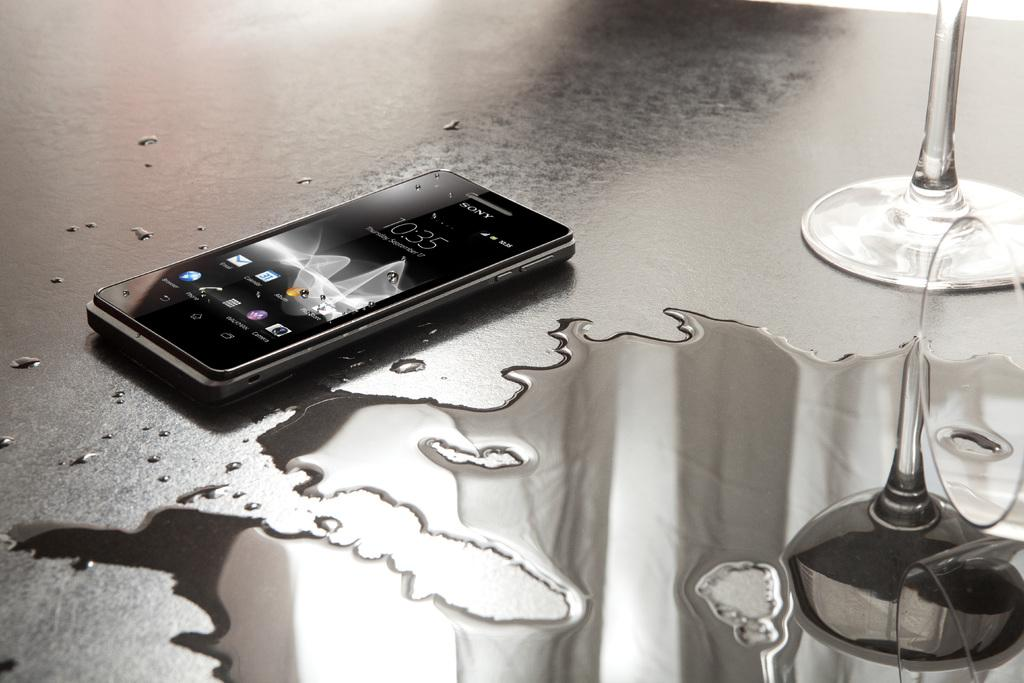What can be seen hanging in the image? There is a mobile in the image. What natural element is visible in the image? There is water visible in the image. What type of object made of glass can be seen in the image? There is a glass object in the image. What is the color of the surface in the image? The surface in the image is black in color. What type of animal can be seen at the airport in the image? There is no airport or animal present in the image. What year is depicted in the image? The image does not depict a specific year; it only shows a mobile, water, a glass object, and a black surface. 